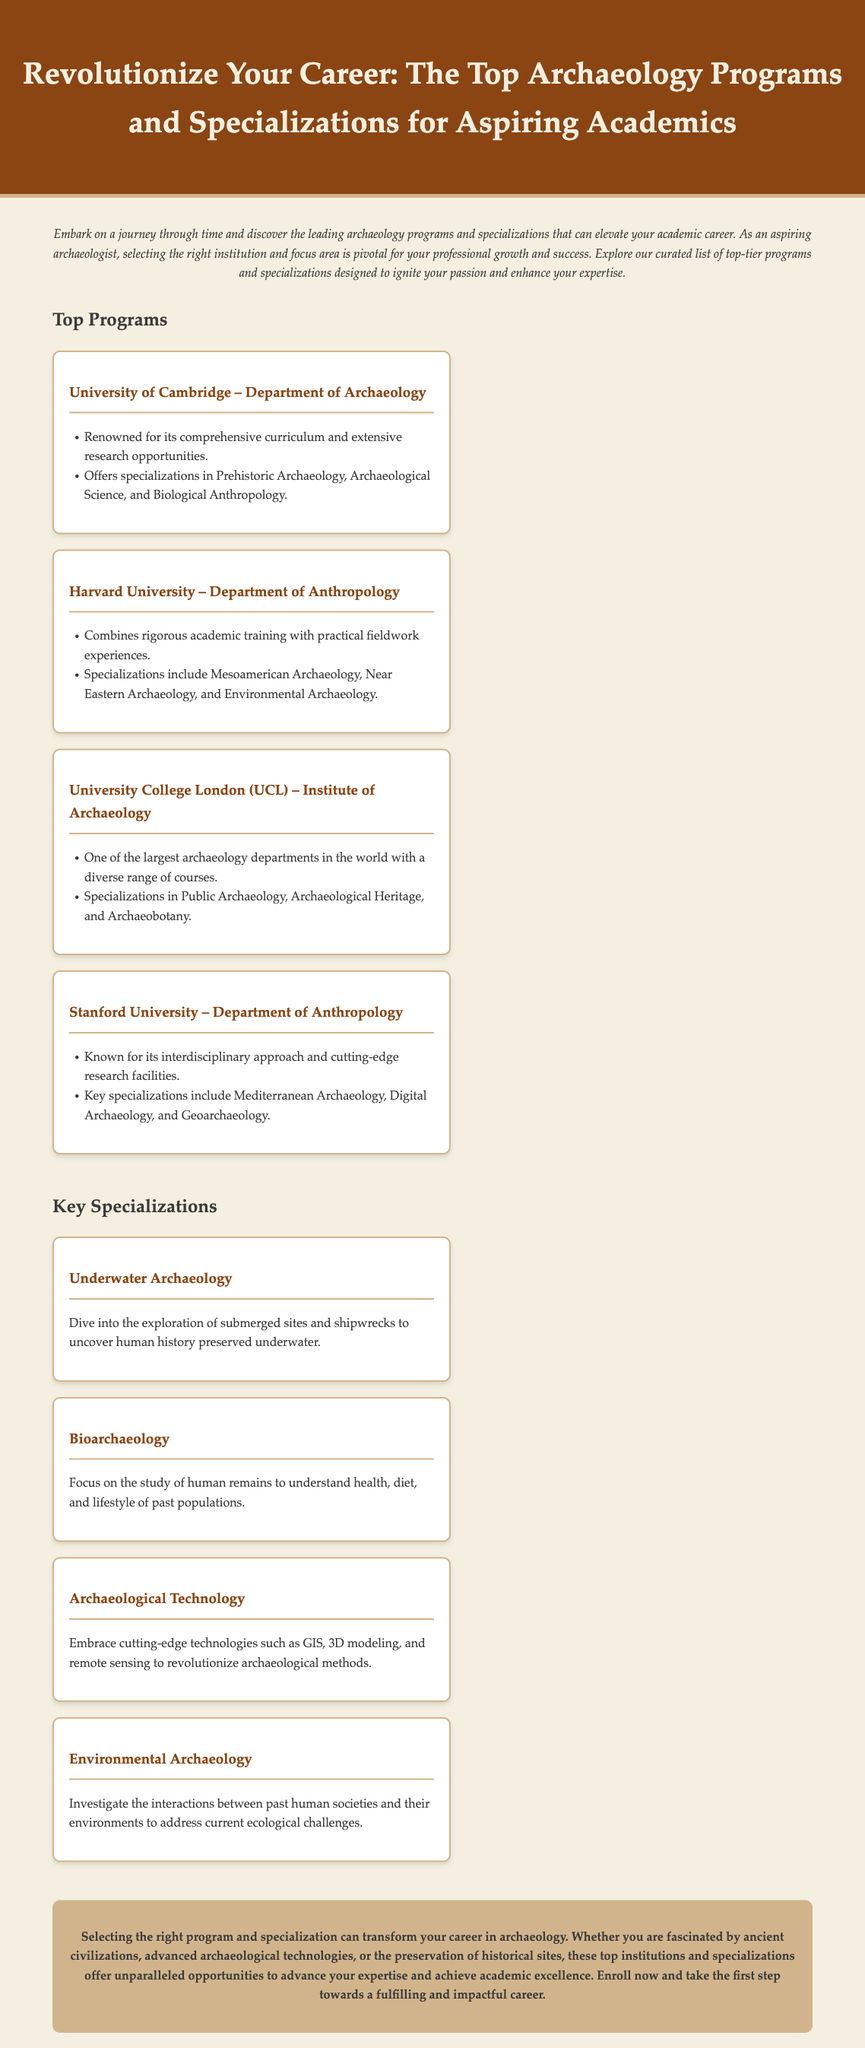What is the title of the advertisement? The title is displayed prominently at the top of the document as a header.
Answer: Revolutionize Your Career: The Top Archaeology Programs and Specializations for Aspiring Academics How many top programs are listed in the document? The document explicitly counts the number of programs in the "Top Programs" section.
Answer: 4 What specialization involves the study of human remains? The document describes the focus of each specialization, indicating their specializations.
Answer: Bioarchaeology Which university is known for its interdisciplinary approach? The document assigns specific characteristics to each university, highlighting their distinct attributes.
Answer: Stanford University What are the specializations offered by the University of Cambridge? The document specifies the specializations associated with each university.
Answer: Prehistoric Archaeology, Archaeological Science, and Biological Anthropology What is the focus of Environmental Archaeology? The document provides a brief description of each specialization, summarizing their areas of study.
Answer: Interactions between past human societies and their environments Which program combines rigorous academic training with practical experiences? The description of each program indicates their unique features and offerings.
Answer: Harvard University – Department of Anthropology What is the concluding statement about selecting the right program? The conclusion summarizes the significance of the right choice in programs and specializations.
Answer: Selecting the right program and specialization can transform your career in archaeology 